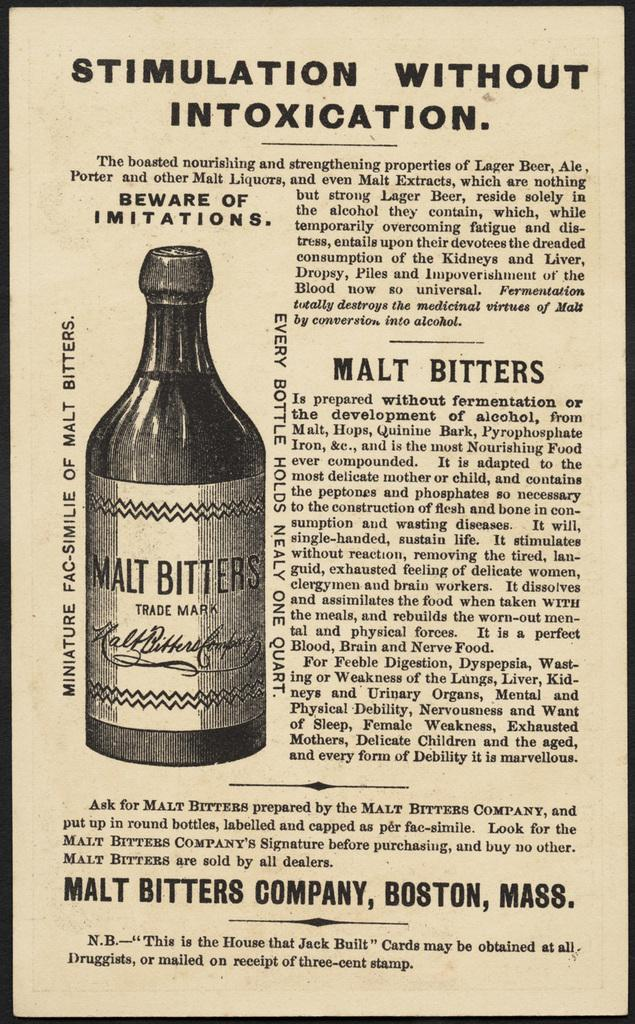<image>
Present a compact description of the photo's key features. A very old article on Malt Bitters, titled Stimulation Without Intoxication warns consumers of other beverages that claim to be as good but aren't. 